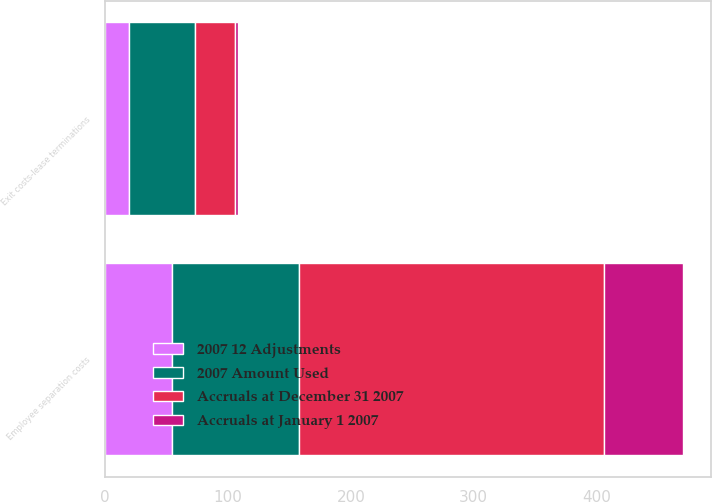<chart> <loc_0><loc_0><loc_500><loc_500><stacked_bar_chart><ecel><fcel>Exit costs-lease terminations<fcel>Employee separation costs<nl><fcel>2007 Amount Used<fcel>54<fcel>104<nl><fcel>2007 12 Adjustments<fcel>19<fcel>54<nl><fcel>Accruals at January 1 2007<fcel>2<fcel>64<nl><fcel>Accruals at December 31 2007<fcel>33<fcel>248<nl></chart> 